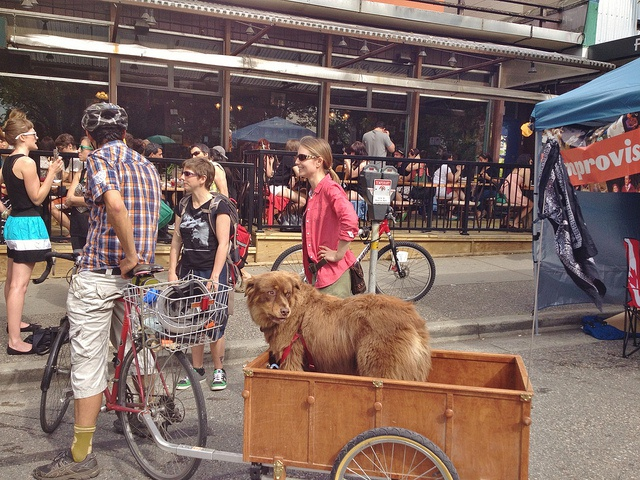Describe the objects in this image and their specific colors. I can see bicycle in black, gray, darkgray, and maroon tones, people in black, lightgray, darkgray, and gray tones, dog in black, gray, tan, brown, and maroon tones, people in black, tan, gray, and cyan tones, and people in black, gray, and tan tones in this image. 